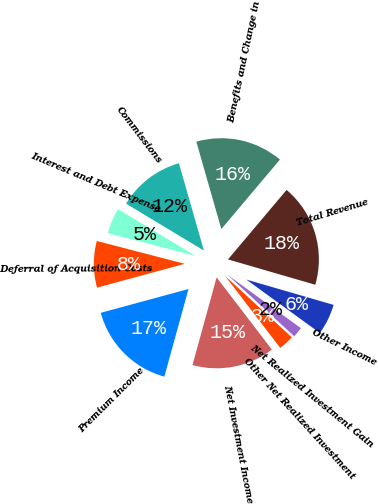Convert chart to OTSL. <chart><loc_0><loc_0><loc_500><loc_500><pie_chart><fcel>Premium Income<fcel>Net Investment Income<fcel>Other Net Realized Investment<fcel>Net Realized Investment Gain<fcel>Other Income<fcel>Total Revenue<fcel>Benefits and Change in<fcel>Commissions<fcel>Interest and Debt Expense<fcel>Deferral of Acquisition Costs<nl><fcel>16.51%<fcel>14.68%<fcel>2.75%<fcel>1.84%<fcel>5.51%<fcel>18.35%<fcel>15.59%<fcel>11.93%<fcel>4.59%<fcel>8.26%<nl></chart> 